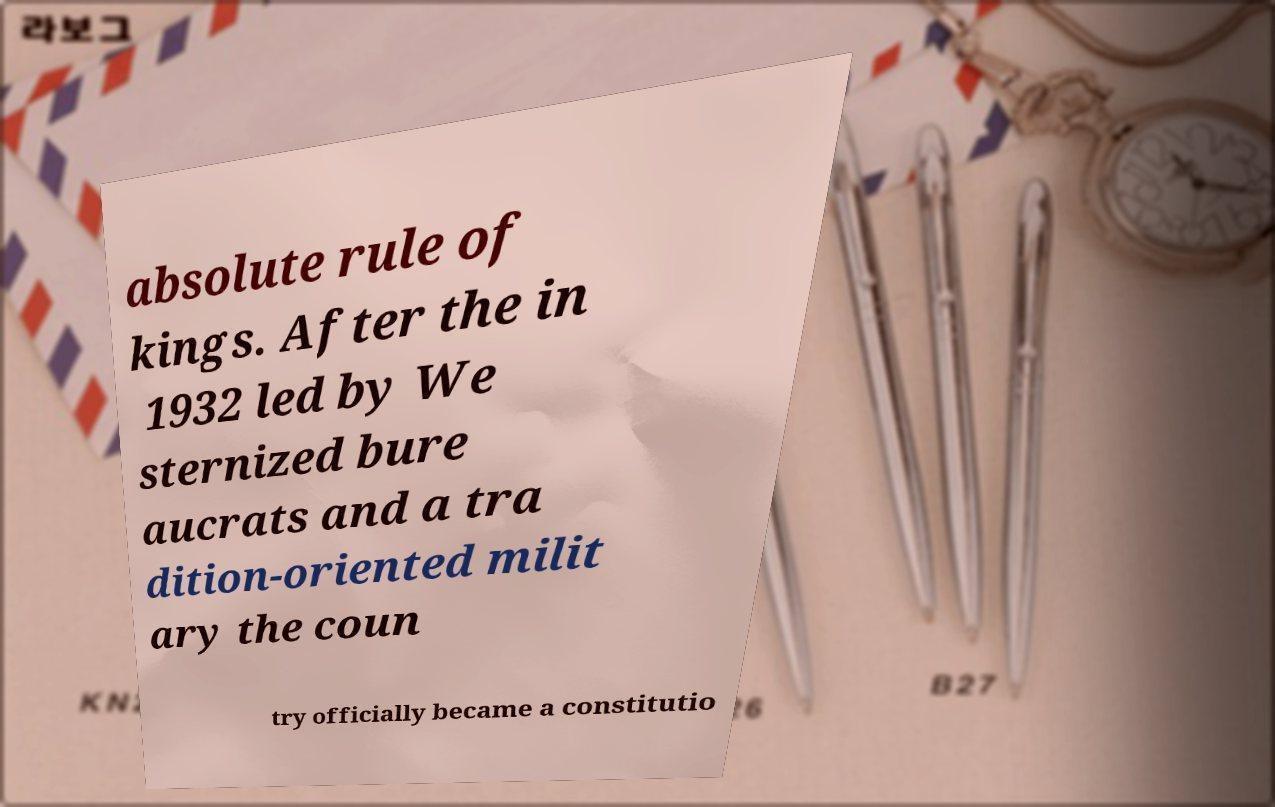I need the written content from this picture converted into text. Can you do that? absolute rule of kings. After the in 1932 led by We sternized bure aucrats and a tra dition-oriented milit ary the coun try officially became a constitutio 